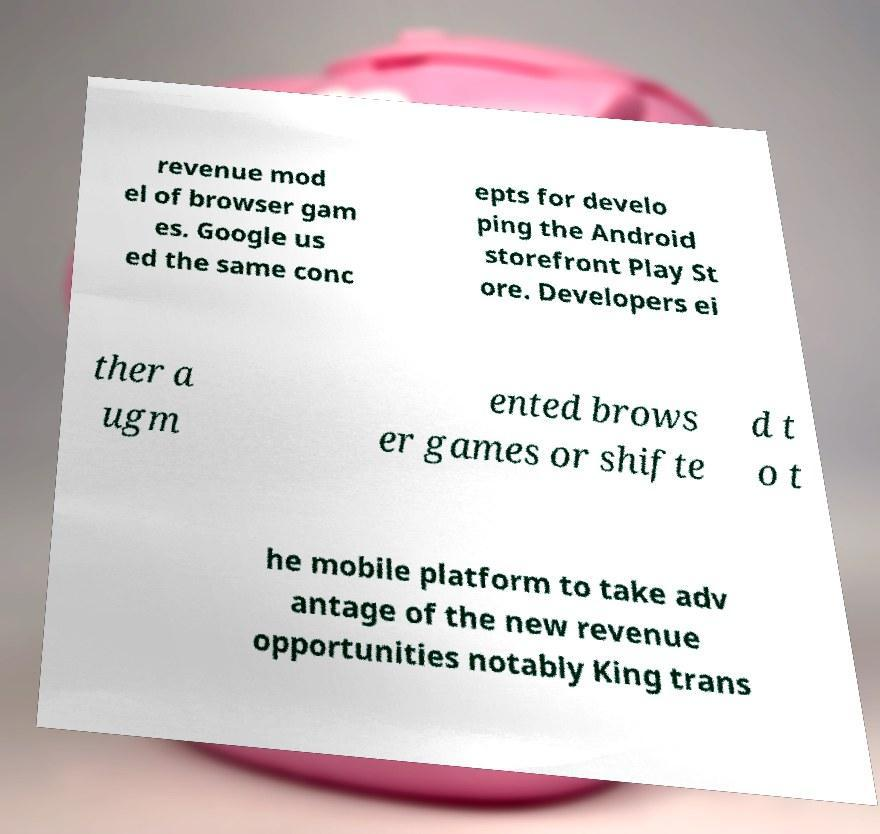What messages or text are displayed in this image? I need them in a readable, typed format. revenue mod el of browser gam es. Google us ed the same conc epts for develo ping the Android storefront Play St ore. Developers ei ther a ugm ented brows er games or shifte d t o t he mobile platform to take adv antage of the new revenue opportunities notably King trans 